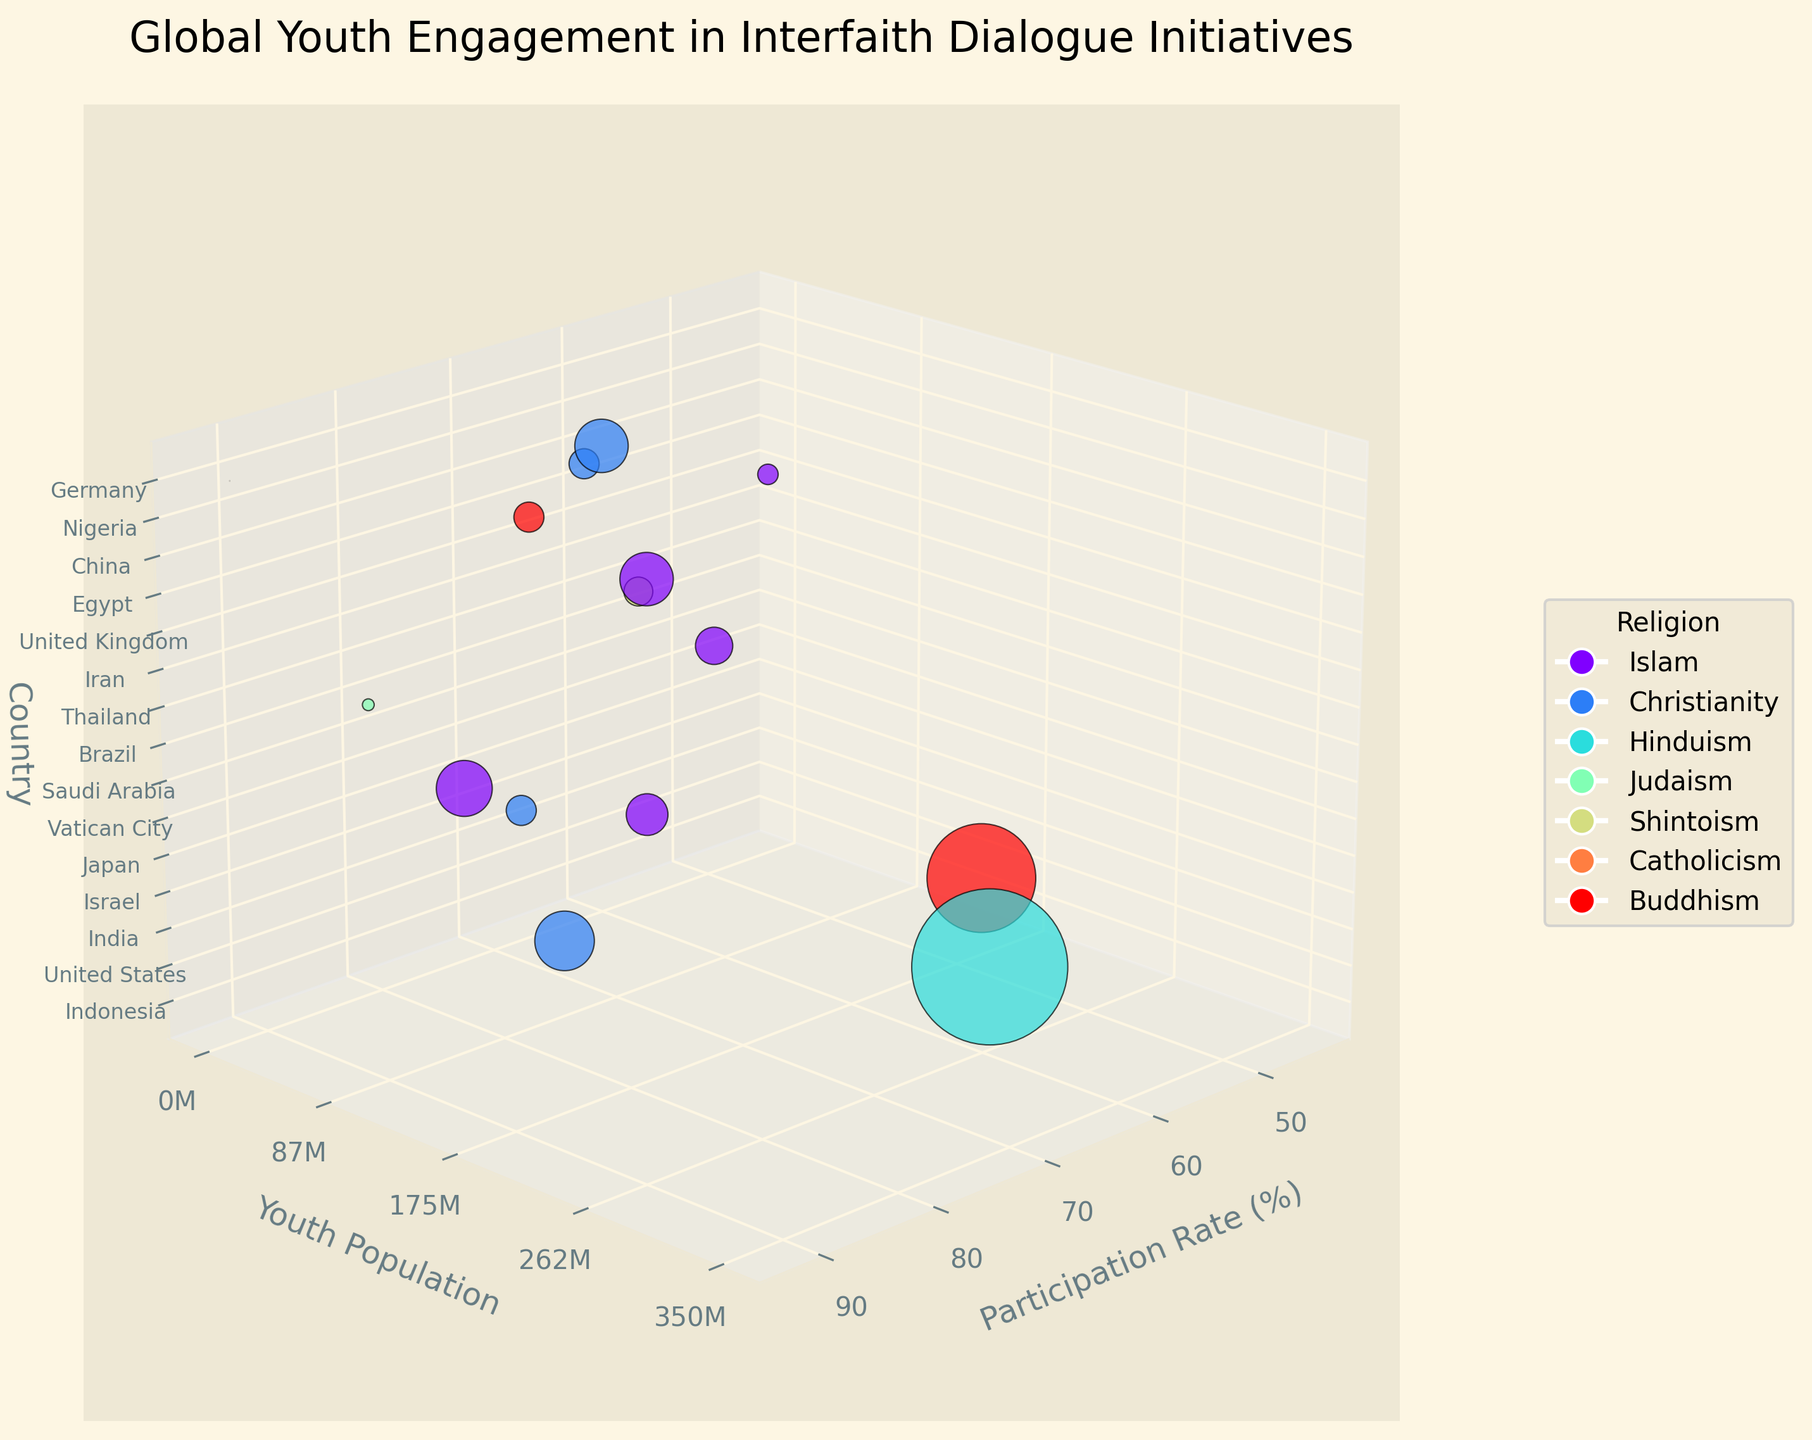What is the participation rate in Vatican City? Look at the data point with the label "Vatican City" on the Z-axis, then refer to the position on the X-axis to find the participation rate.
Answer: 92% Which country has the highest youth population? Identify the data point that is highest on the Y-axis, which represents the youth population. The tallest point corresponds to India.
Answer: India What is the average participation rate of countries with an Islamic religious background? Collect the participation rates for Indonesia, Saudi Arabia, Iran, Egypt, and Nigeria. Sum them up (78 + 45 + 52 + 59 + 61) and divide by the number of countries (5).
Answer: 59% How does the participation rate of Brazil compare to that of the United States? Locate the data points for Brazil and the United States on the Z-axis. Compare their X-axis positions to find their participation rates: Brazil (70) and the United States (65).
Answer: Brazil is higher What size representation indicates youth population in the figure? Observe the scatter plot where the size of each point varies. The figure uses larger points to represent a higher youth population, scaled per 100,000 for readability.
Answer: Point size Which religion appears most frequently in the dataset? Count the data points for each religious background by checking the colors assigned in the legend and corresponding data points on the plot. Islam appears in Indonesia, Saudi Arabia, Iran, Egypt, and Nigeria.
Answer: Islam What is the main title of the figure? Look at the top of the figure where the title is usually located.
Answer: Global Youth Engagement in Interfaith Dialogue Initiatives Which country with a Buddhist background has a higher participation rate, Thailand or China? Identify the data points for Thailand and China on the Z-axis. Compare their positions on the X-axis for participation rates: Thailand (68) and China (47).
Answer: Thailand What is the axis label for the X-axis in the figure? Look at the label on the X-axis within the figure.
Answer: Participation Rate (%) What is the range of the youth population among the countries shown on the plot? Observe the Y-axis, which represents youth population, and note the minimum and maximum values from the figure. The Y-axis ranges from approximately 0 to 350,000,000.
Answer: 0 to 350,000,000 